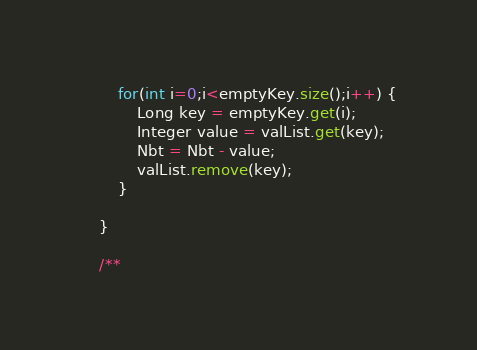Convert code to text. <code><loc_0><loc_0><loc_500><loc_500><_Java_>        for(int i=0;i<emptyKey.size();i++) {
            Long key = emptyKey.get(i);
            Integer value = valList.get(key);
            Nbt = Nbt - value;
            valList.remove(key);
        }

    }

    /**</code> 